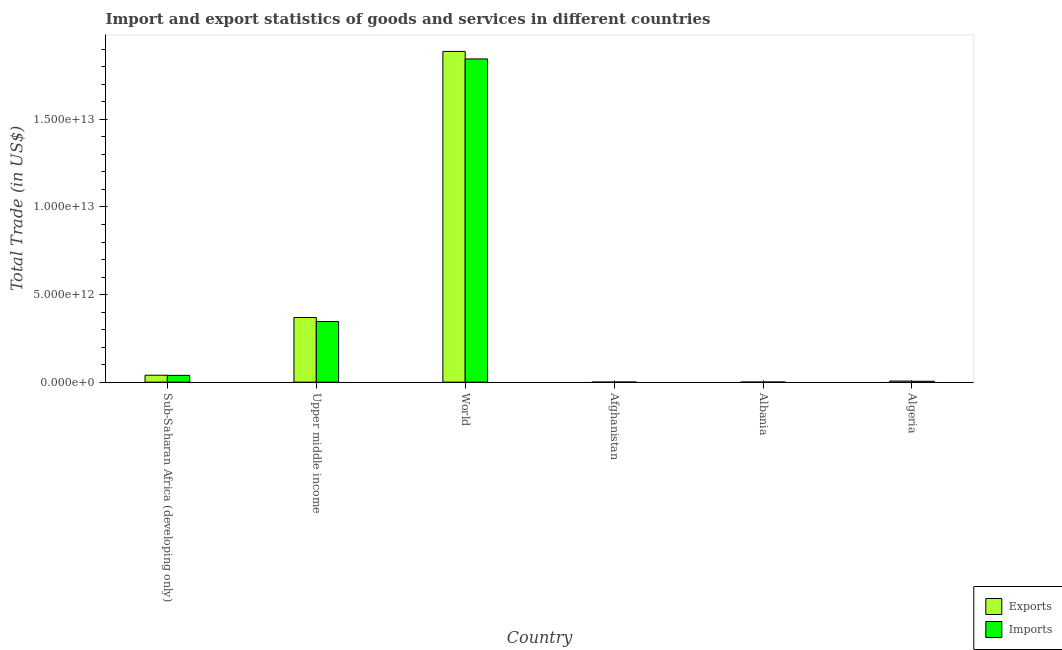Are the number of bars per tick equal to the number of legend labels?
Your response must be concise. Yes. What is the label of the 6th group of bars from the left?
Make the answer very short. Algeria. In how many cases, is the number of bars for a given country not equal to the number of legend labels?
Keep it short and to the point. 0. What is the export of goods and services in Algeria?
Your answer should be compact. 6.20e+1. Across all countries, what is the maximum imports of goods and services?
Provide a short and direct response. 1.85e+13. Across all countries, what is the minimum export of goods and services?
Make the answer very short. 1.60e+09. In which country was the export of goods and services maximum?
Give a very brief answer. World. In which country was the imports of goods and services minimum?
Your answer should be very brief. Albania. What is the total export of goods and services in the graph?
Ensure brevity in your answer.  2.30e+13. What is the difference between the imports of goods and services in Afghanistan and that in Upper middle income?
Provide a short and direct response. -3.45e+12. What is the difference between the imports of goods and services in Upper middle income and the export of goods and services in World?
Offer a terse response. -1.54e+13. What is the average imports of goods and services per country?
Give a very brief answer. 3.73e+12. What is the difference between the imports of goods and services and export of goods and services in Upper middle income?
Provide a short and direct response. -2.29e+11. In how many countries, is the imports of goods and services greater than 11000000000000 US$?
Make the answer very short. 1. What is the ratio of the export of goods and services in Afghanistan to that in World?
Keep it short and to the point. 8.46013854875985e-5. Is the difference between the imports of goods and services in Afghanistan and Albania greater than the difference between the export of goods and services in Afghanistan and Albania?
Your response must be concise. Yes. What is the difference between the highest and the second highest export of goods and services?
Keep it short and to the point. 1.52e+13. What is the difference between the highest and the lowest imports of goods and services?
Ensure brevity in your answer.  1.84e+13. What does the 2nd bar from the left in Sub-Saharan Africa (developing only) represents?
Your answer should be compact. Imports. What does the 2nd bar from the right in World represents?
Your answer should be compact. Exports. Are all the bars in the graph horizontal?
Offer a very short reply. No. What is the difference between two consecutive major ticks on the Y-axis?
Make the answer very short. 5.00e+12. Does the graph contain any zero values?
Provide a succinct answer. No. How many legend labels are there?
Keep it short and to the point. 2. What is the title of the graph?
Provide a short and direct response. Import and export statistics of goods and services in different countries. What is the label or title of the Y-axis?
Keep it short and to the point. Total Trade (in US$). What is the Total Trade (in US$) in Exports in Sub-Saharan Africa (developing only)?
Provide a short and direct response. 3.96e+11. What is the Total Trade (in US$) of Imports in Sub-Saharan Africa (developing only)?
Your answer should be compact. 3.87e+11. What is the Total Trade (in US$) in Exports in Upper middle income?
Provide a short and direct response. 3.69e+12. What is the Total Trade (in US$) in Imports in Upper middle income?
Provide a succinct answer. 3.46e+12. What is the Total Trade (in US$) in Exports in World?
Provide a short and direct response. 1.89e+13. What is the Total Trade (in US$) of Imports in World?
Offer a very short reply. 1.85e+13. What is the Total Trade (in US$) of Exports in Afghanistan?
Your response must be concise. 1.60e+09. What is the Total Trade (in US$) in Imports in Afghanistan?
Ensure brevity in your answer.  7.16e+09. What is the Total Trade (in US$) of Exports in Albania?
Offer a very short reply. 3.87e+09. What is the Total Trade (in US$) of Imports in Albania?
Ensure brevity in your answer.  6.32e+09. What is the Total Trade (in US$) of Exports in Algeria?
Provide a succinct answer. 6.20e+1. What is the Total Trade (in US$) of Imports in Algeria?
Your answer should be very brief. 5.07e+1. Across all countries, what is the maximum Total Trade (in US$) in Exports?
Offer a very short reply. 1.89e+13. Across all countries, what is the maximum Total Trade (in US$) in Imports?
Ensure brevity in your answer.  1.85e+13. Across all countries, what is the minimum Total Trade (in US$) in Exports?
Give a very brief answer. 1.60e+09. Across all countries, what is the minimum Total Trade (in US$) in Imports?
Offer a terse response. 6.32e+09. What is the total Total Trade (in US$) of Exports in the graph?
Provide a short and direct response. 2.30e+13. What is the total Total Trade (in US$) in Imports in the graph?
Make the answer very short. 2.24e+13. What is the difference between the Total Trade (in US$) of Exports in Sub-Saharan Africa (developing only) and that in Upper middle income?
Your answer should be very brief. -3.29e+12. What is the difference between the Total Trade (in US$) in Imports in Sub-Saharan Africa (developing only) and that in Upper middle income?
Provide a succinct answer. -3.07e+12. What is the difference between the Total Trade (in US$) of Exports in Sub-Saharan Africa (developing only) and that in World?
Give a very brief answer. -1.85e+13. What is the difference between the Total Trade (in US$) of Imports in Sub-Saharan Africa (developing only) and that in World?
Ensure brevity in your answer.  -1.81e+13. What is the difference between the Total Trade (in US$) in Exports in Sub-Saharan Africa (developing only) and that in Afghanistan?
Ensure brevity in your answer.  3.94e+11. What is the difference between the Total Trade (in US$) of Imports in Sub-Saharan Africa (developing only) and that in Afghanistan?
Make the answer very short. 3.80e+11. What is the difference between the Total Trade (in US$) of Exports in Sub-Saharan Africa (developing only) and that in Albania?
Your answer should be very brief. 3.92e+11. What is the difference between the Total Trade (in US$) of Imports in Sub-Saharan Africa (developing only) and that in Albania?
Offer a very short reply. 3.81e+11. What is the difference between the Total Trade (in US$) of Exports in Sub-Saharan Africa (developing only) and that in Algeria?
Make the answer very short. 3.34e+11. What is the difference between the Total Trade (in US$) in Imports in Sub-Saharan Africa (developing only) and that in Algeria?
Your response must be concise. 3.36e+11. What is the difference between the Total Trade (in US$) in Exports in Upper middle income and that in World?
Ensure brevity in your answer.  -1.52e+13. What is the difference between the Total Trade (in US$) in Imports in Upper middle income and that in World?
Offer a very short reply. -1.50e+13. What is the difference between the Total Trade (in US$) in Exports in Upper middle income and that in Afghanistan?
Offer a terse response. 3.69e+12. What is the difference between the Total Trade (in US$) in Imports in Upper middle income and that in Afghanistan?
Your answer should be very brief. 3.45e+12. What is the difference between the Total Trade (in US$) of Exports in Upper middle income and that in Albania?
Your answer should be very brief. 3.69e+12. What is the difference between the Total Trade (in US$) of Imports in Upper middle income and that in Albania?
Ensure brevity in your answer.  3.46e+12. What is the difference between the Total Trade (in US$) in Exports in Upper middle income and that in Algeria?
Your answer should be very brief. 3.63e+12. What is the difference between the Total Trade (in US$) of Imports in Upper middle income and that in Algeria?
Give a very brief answer. 3.41e+12. What is the difference between the Total Trade (in US$) of Exports in World and that in Afghanistan?
Offer a terse response. 1.89e+13. What is the difference between the Total Trade (in US$) in Imports in World and that in Afghanistan?
Give a very brief answer. 1.84e+13. What is the difference between the Total Trade (in US$) of Exports in World and that in Albania?
Provide a short and direct response. 1.89e+13. What is the difference between the Total Trade (in US$) in Imports in World and that in Albania?
Offer a terse response. 1.84e+13. What is the difference between the Total Trade (in US$) of Exports in World and that in Algeria?
Offer a very short reply. 1.88e+13. What is the difference between the Total Trade (in US$) of Imports in World and that in Algeria?
Your response must be concise. 1.84e+13. What is the difference between the Total Trade (in US$) in Exports in Afghanistan and that in Albania?
Make the answer very short. -2.27e+09. What is the difference between the Total Trade (in US$) in Imports in Afghanistan and that in Albania?
Ensure brevity in your answer.  8.38e+08. What is the difference between the Total Trade (in US$) in Exports in Afghanistan and that in Algeria?
Your response must be concise. -6.04e+1. What is the difference between the Total Trade (in US$) of Imports in Afghanistan and that in Algeria?
Your response must be concise. -4.35e+1. What is the difference between the Total Trade (in US$) in Exports in Albania and that in Algeria?
Offer a terse response. -5.81e+1. What is the difference between the Total Trade (in US$) in Imports in Albania and that in Algeria?
Your answer should be compact. -4.43e+1. What is the difference between the Total Trade (in US$) in Exports in Sub-Saharan Africa (developing only) and the Total Trade (in US$) in Imports in Upper middle income?
Your answer should be compact. -3.07e+12. What is the difference between the Total Trade (in US$) of Exports in Sub-Saharan Africa (developing only) and the Total Trade (in US$) of Imports in World?
Your answer should be compact. -1.81e+13. What is the difference between the Total Trade (in US$) in Exports in Sub-Saharan Africa (developing only) and the Total Trade (in US$) in Imports in Afghanistan?
Ensure brevity in your answer.  3.89e+11. What is the difference between the Total Trade (in US$) in Exports in Sub-Saharan Africa (developing only) and the Total Trade (in US$) in Imports in Albania?
Keep it short and to the point. 3.90e+11. What is the difference between the Total Trade (in US$) in Exports in Sub-Saharan Africa (developing only) and the Total Trade (in US$) in Imports in Algeria?
Your answer should be compact. 3.45e+11. What is the difference between the Total Trade (in US$) of Exports in Upper middle income and the Total Trade (in US$) of Imports in World?
Your answer should be compact. -1.48e+13. What is the difference between the Total Trade (in US$) in Exports in Upper middle income and the Total Trade (in US$) in Imports in Afghanistan?
Your answer should be very brief. 3.68e+12. What is the difference between the Total Trade (in US$) of Exports in Upper middle income and the Total Trade (in US$) of Imports in Albania?
Give a very brief answer. 3.68e+12. What is the difference between the Total Trade (in US$) of Exports in Upper middle income and the Total Trade (in US$) of Imports in Algeria?
Keep it short and to the point. 3.64e+12. What is the difference between the Total Trade (in US$) in Exports in World and the Total Trade (in US$) in Imports in Afghanistan?
Give a very brief answer. 1.89e+13. What is the difference between the Total Trade (in US$) in Exports in World and the Total Trade (in US$) in Imports in Albania?
Provide a short and direct response. 1.89e+13. What is the difference between the Total Trade (in US$) of Exports in World and the Total Trade (in US$) of Imports in Algeria?
Make the answer very short. 1.88e+13. What is the difference between the Total Trade (in US$) of Exports in Afghanistan and the Total Trade (in US$) of Imports in Albania?
Your answer should be compact. -4.73e+09. What is the difference between the Total Trade (in US$) of Exports in Afghanistan and the Total Trade (in US$) of Imports in Algeria?
Offer a terse response. -4.91e+1. What is the difference between the Total Trade (in US$) of Exports in Albania and the Total Trade (in US$) of Imports in Algeria?
Offer a very short reply. -4.68e+1. What is the average Total Trade (in US$) in Exports per country?
Your answer should be compact. 3.84e+12. What is the average Total Trade (in US$) of Imports per country?
Give a very brief answer. 3.73e+12. What is the difference between the Total Trade (in US$) of Exports and Total Trade (in US$) of Imports in Sub-Saharan Africa (developing only)?
Offer a very short reply. 8.85e+09. What is the difference between the Total Trade (in US$) in Exports and Total Trade (in US$) in Imports in Upper middle income?
Offer a very short reply. 2.29e+11. What is the difference between the Total Trade (in US$) of Exports and Total Trade (in US$) of Imports in World?
Your answer should be compact. 4.30e+11. What is the difference between the Total Trade (in US$) of Exports and Total Trade (in US$) of Imports in Afghanistan?
Keep it short and to the point. -5.57e+09. What is the difference between the Total Trade (in US$) in Exports and Total Trade (in US$) in Imports in Albania?
Your answer should be very brief. -2.46e+09. What is the difference between the Total Trade (in US$) in Exports and Total Trade (in US$) in Imports in Algeria?
Make the answer very short. 1.13e+1. What is the ratio of the Total Trade (in US$) of Exports in Sub-Saharan Africa (developing only) to that in Upper middle income?
Keep it short and to the point. 0.11. What is the ratio of the Total Trade (in US$) in Imports in Sub-Saharan Africa (developing only) to that in Upper middle income?
Offer a very short reply. 0.11. What is the ratio of the Total Trade (in US$) of Exports in Sub-Saharan Africa (developing only) to that in World?
Your answer should be very brief. 0.02. What is the ratio of the Total Trade (in US$) of Imports in Sub-Saharan Africa (developing only) to that in World?
Provide a short and direct response. 0.02. What is the ratio of the Total Trade (in US$) of Exports in Sub-Saharan Africa (developing only) to that in Afghanistan?
Provide a succinct answer. 247.88. What is the ratio of the Total Trade (in US$) of Imports in Sub-Saharan Africa (developing only) to that in Afghanistan?
Offer a terse response. 54.05. What is the ratio of the Total Trade (in US$) in Exports in Sub-Saharan Africa (developing only) to that in Albania?
Offer a very short reply. 102.34. What is the ratio of the Total Trade (in US$) in Imports in Sub-Saharan Africa (developing only) to that in Albania?
Your response must be concise. 61.21. What is the ratio of the Total Trade (in US$) in Exports in Sub-Saharan Africa (developing only) to that in Algeria?
Keep it short and to the point. 6.39. What is the ratio of the Total Trade (in US$) in Imports in Sub-Saharan Africa (developing only) to that in Algeria?
Provide a succinct answer. 7.64. What is the ratio of the Total Trade (in US$) of Exports in Upper middle income to that in World?
Offer a very short reply. 0.2. What is the ratio of the Total Trade (in US$) of Imports in Upper middle income to that in World?
Provide a short and direct response. 0.19. What is the ratio of the Total Trade (in US$) in Exports in Upper middle income to that in Afghanistan?
Offer a terse response. 2310.29. What is the ratio of the Total Trade (in US$) of Imports in Upper middle income to that in Afghanistan?
Offer a terse response. 483.27. What is the ratio of the Total Trade (in US$) of Exports in Upper middle income to that in Albania?
Offer a very short reply. 953.87. What is the ratio of the Total Trade (in US$) in Imports in Upper middle income to that in Albania?
Keep it short and to the point. 547.34. What is the ratio of the Total Trade (in US$) of Exports in Upper middle income to that in Algeria?
Offer a very short reply. 59.55. What is the ratio of the Total Trade (in US$) in Imports in Upper middle income to that in Algeria?
Your answer should be compact. 68.33. What is the ratio of the Total Trade (in US$) of Exports in World to that in Afghanistan?
Make the answer very short. 1.18e+04. What is the ratio of the Total Trade (in US$) of Imports in World to that in Afghanistan?
Offer a very short reply. 2576.2. What is the ratio of the Total Trade (in US$) in Exports in World to that in Albania?
Keep it short and to the point. 4880.31. What is the ratio of the Total Trade (in US$) of Imports in World to that in Albania?
Provide a succinct answer. 2917.7. What is the ratio of the Total Trade (in US$) in Exports in World to that in Algeria?
Offer a very short reply. 304.68. What is the ratio of the Total Trade (in US$) of Imports in World to that in Algeria?
Offer a very short reply. 364.27. What is the ratio of the Total Trade (in US$) of Exports in Afghanistan to that in Albania?
Ensure brevity in your answer.  0.41. What is the ratio of the Total Trade (in US$) in Imports in Afghanistan to that in Albania?
Keep it short and to the point. 1.13. What is the ratio of the Total Trade (in US$) of Exports in Afghanistan to that in Algeria?
Your answer should be very brief. 0.03. What is the ratio of the Total Trade (in US$) in Imports in Afghanistan to that in Algeria?
Your response must be concise. 0.14. What is the ratio of the Total Trade (in US$) of Exports in Albania to that in Algeria?
Offer a very short reply. 0.06. What is the ratio of the Total Trade (in US$) in Imports in Albania to that in Algeria?
Provide a short and direct response. 0.12. What is the difference between the highest and the second highest Total Trade (in US$) of Exports?
Offer a terse response. 1.52e+13. What is the difference between the highest and the second highest Total Trade (in US$) in Imports?
Ensure brevity in your answer.  1.50e+13. What is the difference between the highest and the lowest Total Trade (in US$) of Exports?
Your response must be concise. 1.89e+13. What is the difference between the highest and the lowest Total Trade (in US$) of Imports?
Your response must be concise. 1.84e+13. 